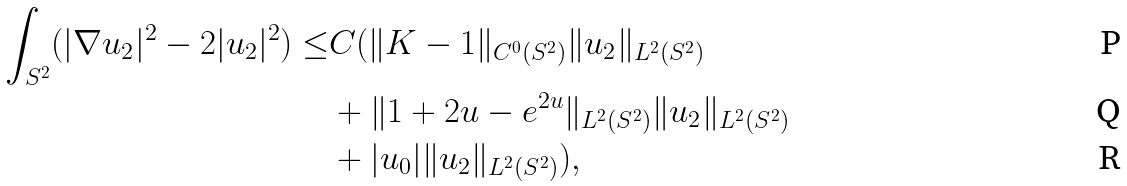Convert formula to latex. <formula><loc_0><loc_0><loc_500><loc_500>\int _ { S ^ { 2 } } ( | \nabla u _ { 2 } | ^ { 2 } - 2 | u _ { 2 } | ^ { 2 } ) \leq & C ( \| K - 1 \| _ { C ^ { 0 } ( S ^ { 2 } ) } \| u _ { 2 } \| _ { L ^ { 2 } ( S ^ { 2 } ) } \\ & + \| 1 + 2 u - e ^ { 2 u } \| _ { L ^ { 2 } ( S ^ { 2 } ) } \| u _ { 2 } \| _ { L ^ { 2 } ( S ^ { 2 } ) } \\ & + | u _ { 0 } | \| u _ { 2 } \| _ { L ^ { 2 } ( S ^ { 2 } ) } ) ,</formula> 